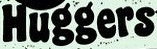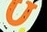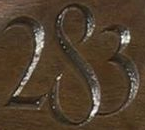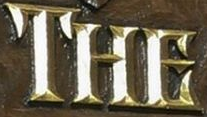What text appears in these images from left to right, separated by a semicolon? Huggers; U; 283; THE 